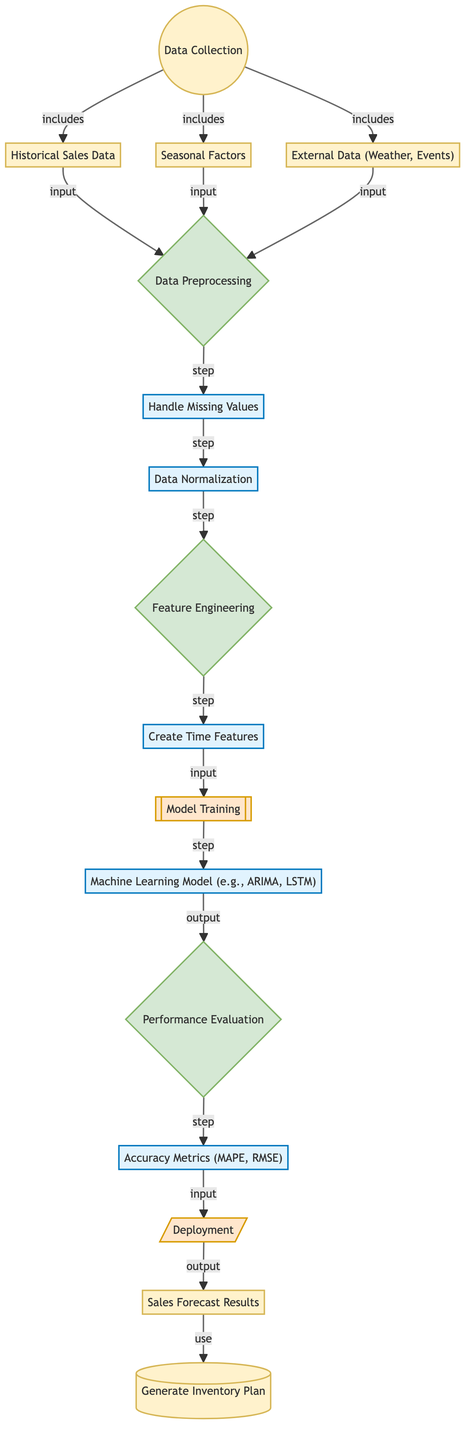What are the three sources included in data collection? The diagram lists historical sales data, seasonal factors, and external data as the three sources involved in the data collection step.
Answer: Historical Sales Data, Seasonal Factors, External Data What is the first step after data preprocessing? The diagram shows that after data preprocessing, the next step is feature engineering, indicating the flow of the process.
Answer: Feature Engineering How many steps are there in the feature engineering process? The diagram indicates that there are three distinct steps under feature engineering: creating time features and two preceding steps all connected in a sequence that includes handling time features as a part of feature engineering.
Answer: Two Which node outputs the results that are used for inventory planning? The forecast results node outputs the insights, which directly feed into generating the inventory plan, as shown in the diagram's flow.
Answer: Forecast Results What type of model is represented in the machine learning model node? The diagram indicates that the machine learning model represents various algorithms like ARIMA and LSTM, which are commonly used for forecasting tasks.
Answer: ARIMA, LSTM What metrics are used for performance evaluation? The diagram specifies that accuracy metrics such as MAPE and RMSE are utilized for evaluating the model's performance, indicating the effectiveness of the forecasting.
Answer: MAPE, RMSE Which stage comes after model training? According to the flow of the diagram, after model training, the process proceeds to performance evaluation, indicating the sequence of steps required for assessing the model.
Answer: Performance Evaluation What step directly follows handling missing values? The diagram shows that after handling missing values, the next step is data normalization, outlining the order of data preprocessing tasks clearly.
Answer: Data Normalization What is the purpose of the deployment step? The deployment step serves to apply the trained model and make predictions, leading to the forecast results that are utilized in inventory planning, as displayed in the diagram.
Answer: Apply predictions 